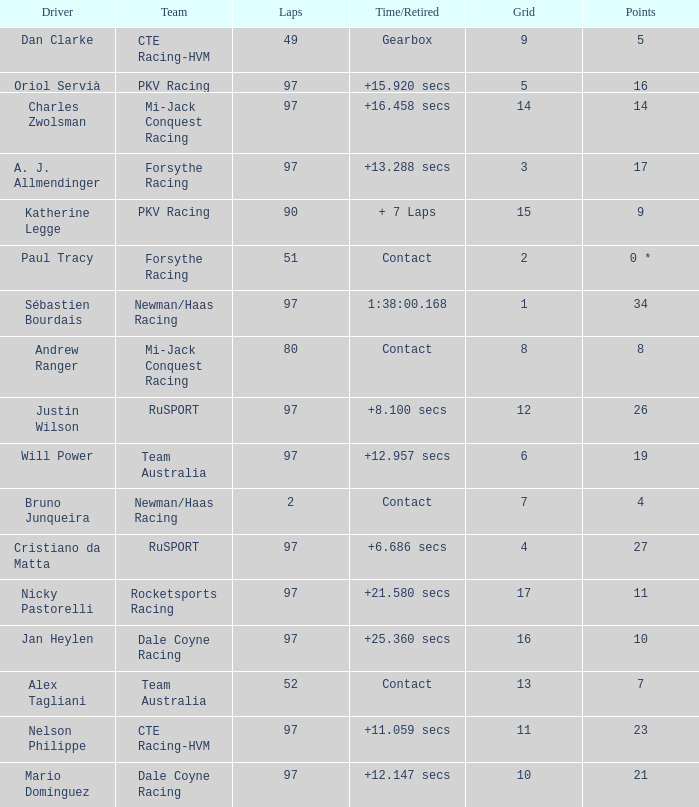What is the highest number of laps for the driver with 5 points? 49.0. 